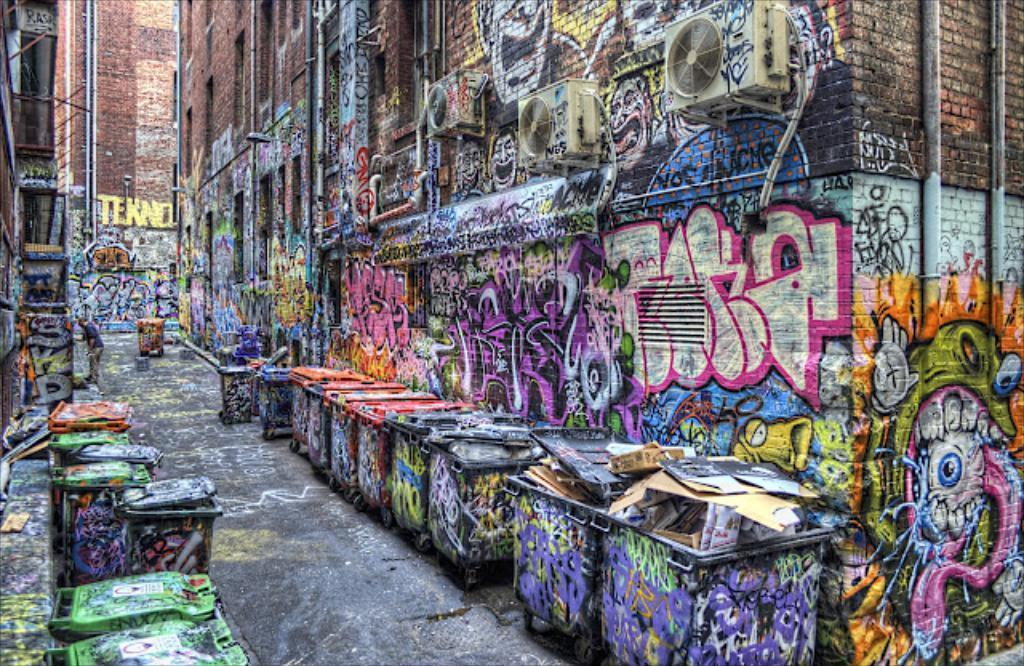In one or two sentences, can you explain what this image depicts? In this image, we can see a person and there are bins and some card boards and in the background, we can see air conditioners and we can see graffiti on the buildings. At the bottom, there is a road. 